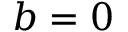Convert formula to latex. <formula><loc_0><loc_0><loc_500><loc_500>b = 0</formula> 